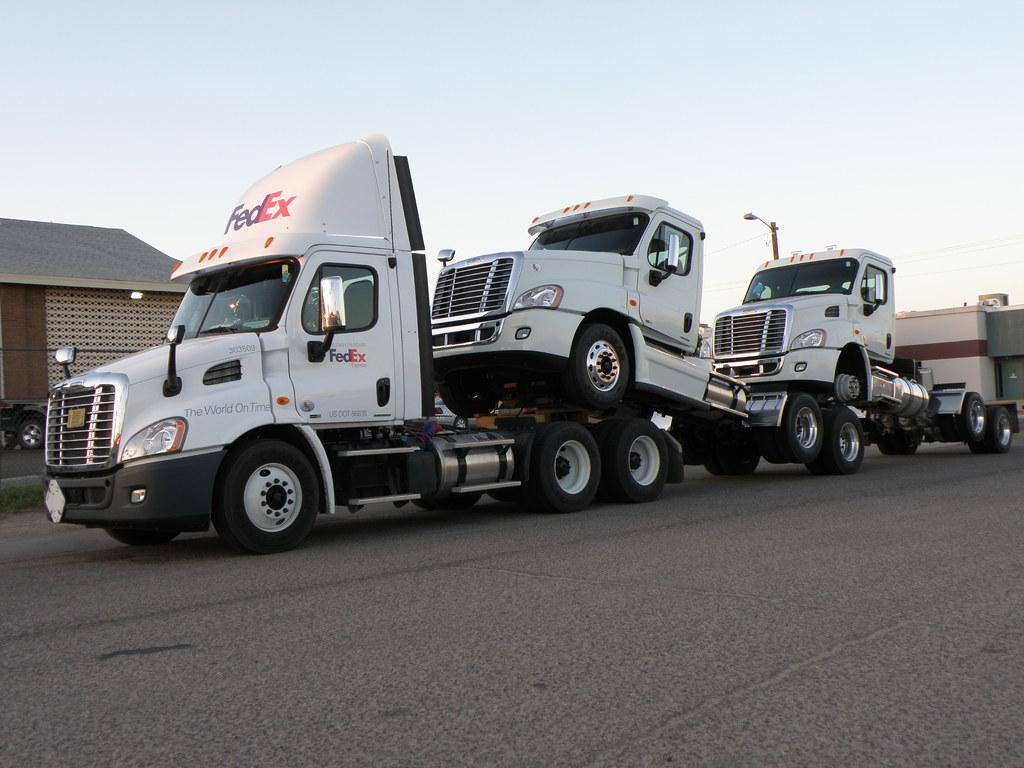What type of vehicles can be seen on the road in the image? There are trucks on the road in the image. What type of structures are visible in the image? There are houses visible in the image. Where is the market located in the image? There is no market present in the image. What type of society is depicted in the image? The image does not depict a society; it shows trucks on the road and houses. 